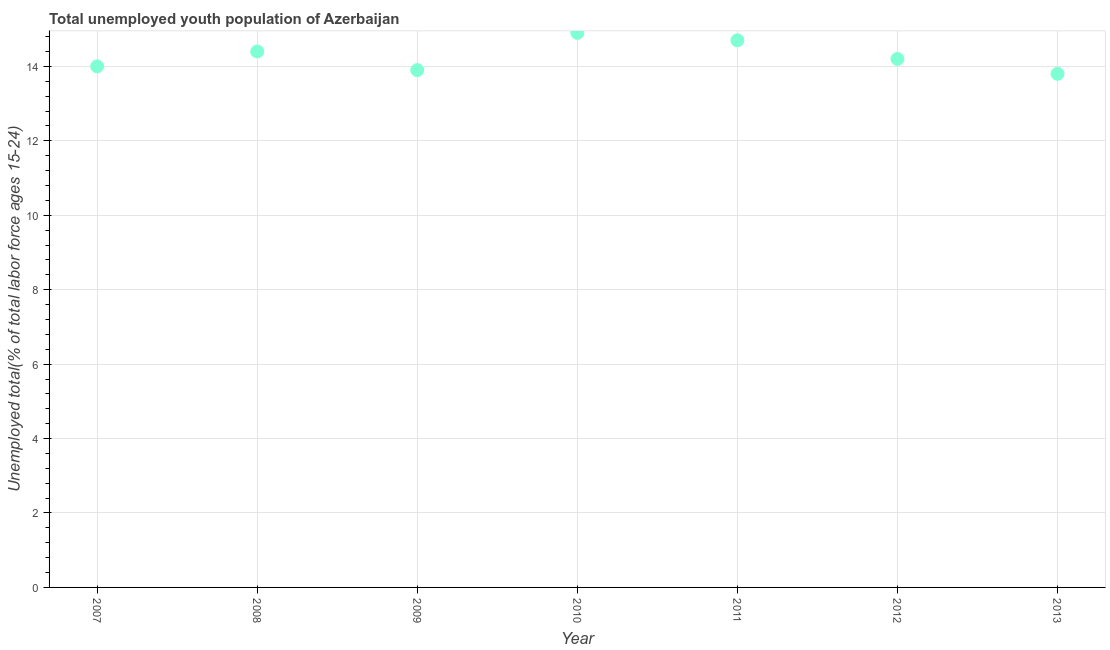What is the unemployed youth in 2012?
Provide a succinct answer. 14.2. Across all years, what is the maximum unemployed youth?
Keep it short and to the point. 14.9. Across all years, what is the minimum unemployed youth?
Provide a succinct answer. 13.8. In which year was the unemployed youth maximum?
Provide a short and direct response. 2010. What is the sum of the unemployed youth?
Your response must be concise. 99.9. What is the difference between the unemployed youth in 2012 and 2013?
Ensure brevity in your answer.  0.4. What is the average unemployed youth per year?
Provide a short and direct response. 14.27. What is the median unemployed youth?
Your answer should be compact. 14.2. Do a majority of the years between 2010 and 2011 (inclusive) have unemployed youth greater than 2.8 %?
Provide a succinct answer. Yes. What is the ratio of the unemployed youth in 2010 to that in 2013?
Provide a short and direct response. 1.08. Is the difference between the unemployed youth in 2007 and 2008 greater than the difference between any two years?
Make the answer very short. No. What is the difference between the highest and the second highest unemployed youth?
Provide a short and direct response. 0.2. What is the difference between the highest and the lowest unemployed youth?
Ensure brevity in your answer.  1.1. In how many years, is the unemployed youth greater than the average unemployed youth taken over all years?
Ensure brevity in your answer.  3. Does the unemployed youth monotonically increase over the years?
Provide a short and direct response. No. How many dotlines are there?
Provide a succinct answer. 1. How many years are there in the graph?
Your response must be concise. 7. Are the values on the major ticks of Y-axis written in scientific E-notation?
Offer a terse response. No. What is the title of the graph?
Give a very brief answer. Total unemployed youth population of Azerbaijan. What is the label or title of the X-axis?
Make the answer very short. Year. What is the label or title of the Y-axis?
Offer a terse response. Unemployed total(% of total labor force ages 15-24). What is the Unemployed total(% of total labor force ages 15-24) in 2008?
Offer a terse response. 14.4. What is the Unemployed total(% of total labor force ages 15-24) in 2009?
Give a very brief answer. 13.9. What is the Unemployed total(% of total labor force ages 15-24) in 2010?
Ensure brevity in your answer.  14.9. What is the Unemployed total(% of total labor force ages 15-24) in 2011?
Make the answer very short. 14.7. What is the Unemployed total(% of total labor force ages 15-24) in 2012?
Offer a very short reply. 14.2. What is the Unemployed total(% of total labor force ages 15-24) in 2013?
Your answer should be very brief. 13.8. What is the difference between the Unemployed total(% of total labor force ages 15-24) in 2007 and 2009?
Provide a succinct answer. 0.1. What is the difference between the Unemployed total(% of total labor force ages 15-24) in 2007 and 2010?
Your answer should be very brief. -0.9. What is the difference between the Unemployed total(% of total labor force ages 15-24) in 2007 and 2011?
Your answer should be very brief. -0.7. What is the difference between the Unemployed total(% of total labor force ages 15-24) in 2008 and 2011?
Provide a short and direct response. -0.3. What is the difference between the Unemployed total(% of total labor force ages 15-24) in 2008 and 2013?
Your answer should be compact. 0.6. What is the difference between the Unemployed total(% of total labor force ages 15-24) in 2009 and 2010?
Offer a terse response. -1. What is the difference between the Unemployed total(% of total labor force ages 15-24) in 2009 and 2011?
Your response must be concise. -0.8. What is the difference between the Unemployed total(% of total labor force ages 15-24) in 2009 and 2013?
Keep it short and to the point. 0.1. What is the difference between the Unemployed total(% of total labor force ages 15-24) in 2010 and 2012?
Give a very brief answer. 0.7. What is the difference between the Unemployed total(% of total labor force ages 15-24) in 2010 and 2013?
Offer a terse response. 1.1. What is the difference between the Unemployed total(% of total labor force ages 15-24) in 2011 and 2012?
Your answer should be very brief. 0.5. What is the difference between the Unemployed total(% of total labor force ages 15-24) in 2011 and 2013?
Your answer should be very brief. 0.9. What is the difference between the Unemployed total(% of total labor force ages 15-24) in 2012 and 2013?
Offer a terse response. 0.4. What is the ratio of the Unemployed total(% of total labor force ages 15-24) in 2007 to that in 2008?
Provide a short and direct response. 0.97. What is the ratio of the Unemployed total(% of total labor force ages 15-24) in 2007 to that in 2010?
Provide a short and direct response. 0.94. What is the ratio of the Unemployed total(% of total labor force ages 15-24) in 2007 to that in 2011?
Provide a succinct answer. 0.95. What is the ratio of the Unemployed total(% of total labor force ages 15-24) in 2007 to that in 2013?
Give a very brief answer. 1.01. What is the ratio of the Unemployed total(% of total labor force ages 15-24) in 2008 to that in 2009?
Your answer should be very brief. 1.04. What is the ratio of the Unemployed total(% of total labor force ages 15-24) in 2008 to that in 2011?
Ensure brevity in your answer.  0.98. What is the ratio of the Unemployed total(% of total labor force ages 15-24) in 2008 to that in 2013?
Your response must be concise. 1.04. What is the ratio of the Unemployed total(% of total labor force ages 15-24) in 2009 to that in 2010?
Give a very brief answer. 0.93. What is the ratio of the Unemployed total(% of total labor force ages 15-24) in 2009 to that in 2011?
Ensure brevity in your answer.  0.95. What is the ratio of the Unemployed total(% of total labor force ages 15-24) in 2009 to that in 2012?
Your answer should be compact. 0.98. What is the ratio of the Unemployed total(% of total labor force ages 15-24) in 2009 to that in 2013?
Make the answer very short. 1.01. What is the ratio of the Unemployed total(% of total labor force ages 15-24) in 2010 to that in 2011?
Provide a succinct answer. 1.01. What is the ratio of the Unemployed total(% of total labor force ages 15-24) in 2010 to that in 2012?
Offer a terse response. 1.05. What is the ratio of the Unemployed total(% of total labor force ages 15-24) in 2010 to that in 2013?
Ensure brevity in your answer.  1.08. What is the ratio of the Unemployed total(% of total labor force ages 15-24) in 2011 to that in 2012?
Give a very brief answer. 1.03. What is the ratio of the Unemployed total(% of total labor force ages 15-24) in 2011 to that in 2013?
Make the answer very short. 1.06. What is the ratio of the Unemployed total(% of total labor force ages 15-24) in 2012 to that in 2013?
Make the answer very short. 1.03. 